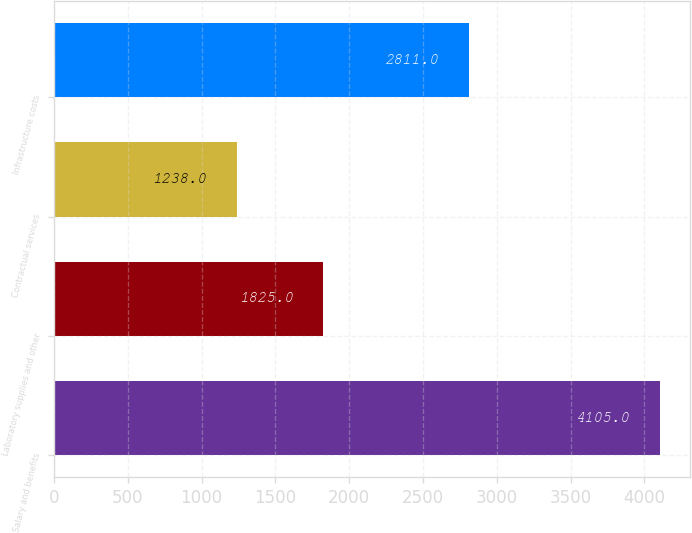Convert chart. <chart><loc_0><loc_0><loc_500><loc_500><bar_chart><fcel>Salary and benefits<fcel>Laboratory supplies and other<fcel>Contractual services<fcel>Infrastructure costs<nl><fcel>4105<fcel>1825<fcel>1238<fcel>2811<nl></chart> 